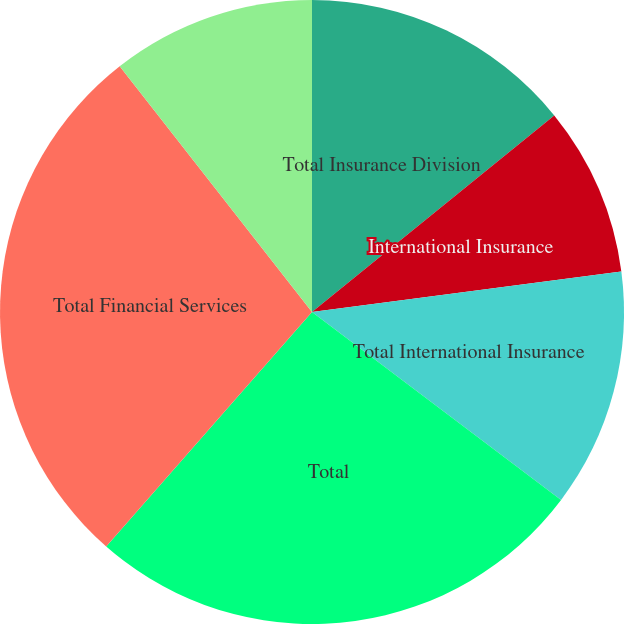<chart> <loc_0><loc_0><loc_500><loc_500><pie_chart><fcel>Total Insurance Division<fcel>International Insurance<fcel>Total International Insurance<fcel>Total<fcel>Total Financial Services<fcel>Closed Block Business<nl><fcel>14.15%<fcel>8.78%<fcel>12.36%<fcel>26.18%<fcel>27.97%<fcel>10.57%<nl></chart> 